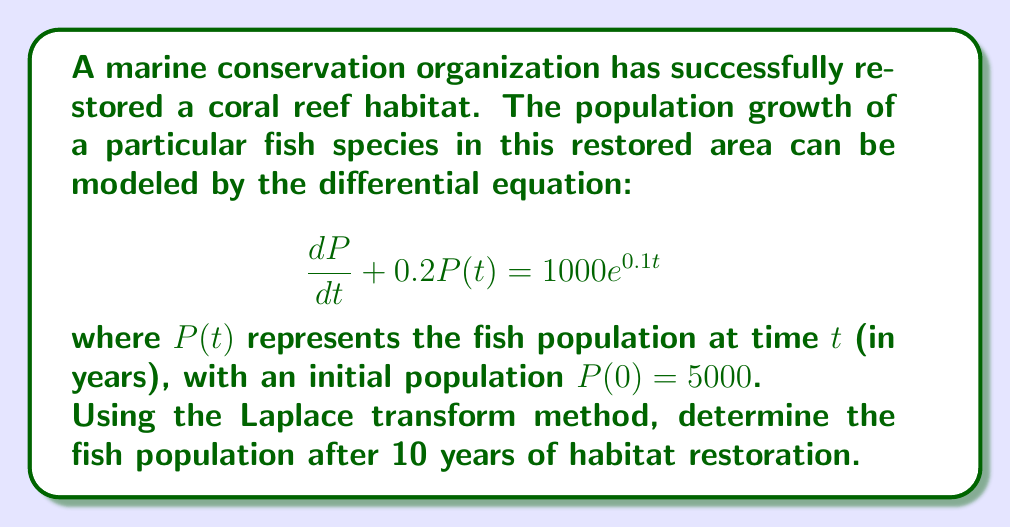Provide a solution to this math problem. Let's solve this problem step by step using the Laplace transform method:

1) Take the Laplace transform of both sides of the equation:
   $$\mathcal{L}\left\{\frac{dP}{dt} + 0.2P(t)\right\} = \mathcal{L}\{1000e^{0.1t}\}$$

2) Using Laplace transform properties:
   $$sP(s) - P(0) + 0.2P(s) = \frac{1000}{s-0.1}$$

3) Substitute $P(0) = 5000$:
   $$sP(s) - 5000 + 0.2P(s) = \frac{1000}{s-0.1}$$

4) Rearrange the equation:
   $$(s+0.2)P(s) = \frac{1000}{s-0.1} + 5000$$

5) Solve for $P(s)$:
   $$P(s) = \frac{1000}{(s+0.2)(s-0.1)} + \frac{5000}{s+0.2}$$

6) Decompose into partial fractions:
   $$P(s) = \frac{A}{s+0.2} + \frac{B}{s-0.1} + \frac{5000}{s+0.2}$$
   
   where $A = -3333.33$ and $B = 3333.33$

7) Take the inverse Laplace transform:
   $$P(t) = -3333.33e^{-0.2t} + 3333.33e^{0.1t} + 5000e^{-0.2t}$$

8) Simplify:
   $$P(t) = 3333.33e^{0.1t} + 1666.67e^{-0.2t}$$

9) To find the population after 10 years, substitute $t = 10$:
   $$P(10) = 3333.33e^{0.1(10)} + 1666.67e^{-0.2(10)}$$
   $$P(10) = 3333.33e^1 + 1666.67e^{-2}$$
   $$P(10) = 9060.47 + 225.51 = 9285.98$$
Answer: 9286 fish (rounded to nearest whole number) 